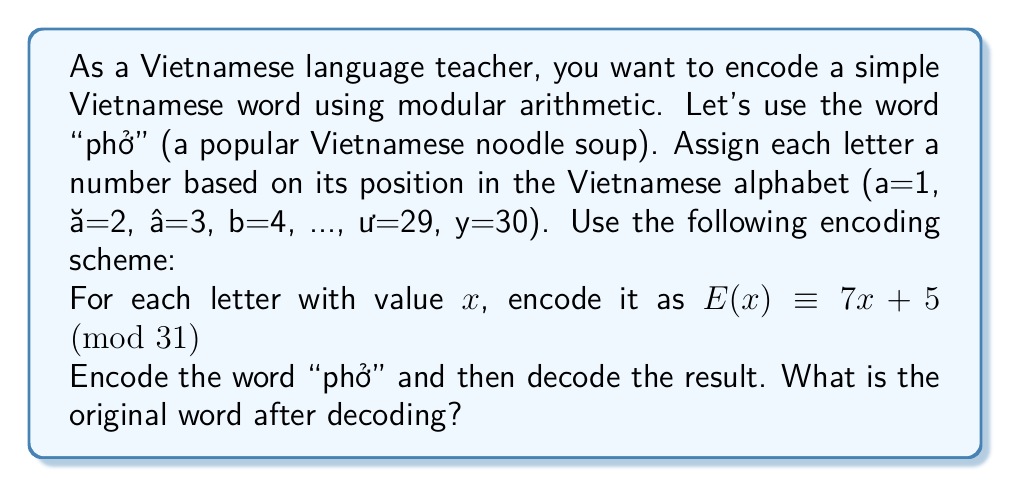Provide a solution to this math problem. Let's approach this step-by-step:

1) First, we need to assign numbers to the letters in "phở":
   p = 20, h = 10, ở = 19

2) Now, we encode each letter using the given formula $E(x) \equiv 7x + 5 \pmod{31}$:

   For p (20): $E(20) \equiv 7(20) + 5 \equiv 145 \equiv 21 \pmod{31}$
   For h (10): $E(10) \equiv 7(10) + 5 \equiv 75 \equiv 13 \pmod{31}$
   For ở (19): $E(19) \equiv 7(19) + 5 \equiv 138 \equiv 14 \pmod{31}$

   So, the encoded word is 21 13 14

3) To decode, we need to find the inverse function. We can do this by solving:
   $7x + 5 \equiv y \pmod{31}$
   $7x \equiv y - 5 \pmod{31}$
   $x \equiv 7^{-1}(y - 5) \pmod{31}$

4) We need to find $7^{-1} \pmod{31}$. We can do this by trying values:
   $7 \cdot 9 = 63 \equiv 1 \pmod{31}$
   So, $7^{-1} \equiv 9 \pmod{31}$

5) Therefore, our decoding function is:
   $D(y) \equiv 9(y - 5) \pmod{31}$

6) Now let's decode each number:

   For 21: $D(21) \equiv 9(21 - 5) \equiv 9(16) \equiv 144 \equiv 20 \pmod{31}$
   For 13: $D(13) \equiv 9(13 - 5) \equiv 9(8) \equiv 72 \equiv 10 \pmod{31}$
   For 14: $D(14) \equiv 9(14 - 5) \equiv 9(9) \equiv 81 \equiv 19 \pmod{31}$

7) Converting these numbers back to letters:
   20 = p, 10 = h, 19 = ở

Therefore, the decoded word is "phở", which matches our original word.
Answer: The original word after decoding is "phở". 